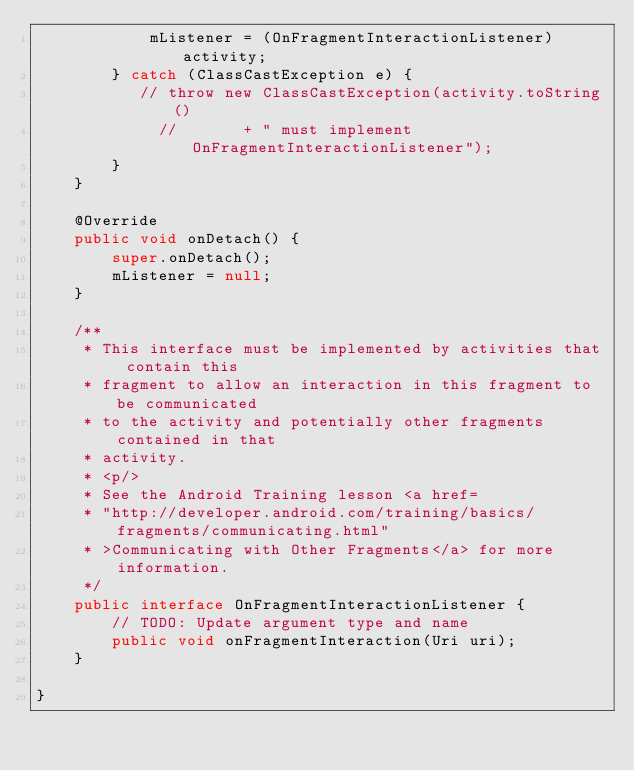<code> <loc_0><loc_0><loc_500><loc_500><_Java_>            mListener = (OnFragmentInteractionListener) activity;
        } catch (ClassCastException e) {
           // throw new ClassCastException(activity.toString()
             //       + " must implement OnFragmentInteractionListener");
        }
    }

    @Override
    public void onDetach() {
        super.onDetach();
        mListener = null;
    }

    /**
     * This interface must be implemented by activities that contain this
     * fragment to allow an interaction in this fragment to be communicated
     * to the activity and potentially other fragments contained in that
     * activity.
     * <p/>
     * See the Android Training lesson <a href=
     * "http://developer.android.com/training/basics/fragments/communicating.html"
     * >Communicating with Other Fragments</a> for more information.
     */
    public interface OnFragmentInteractionListener {
        // TODO: Update argument type and name
        public void onFragmentInteraction(Uri uri);
    }

}
</code> 